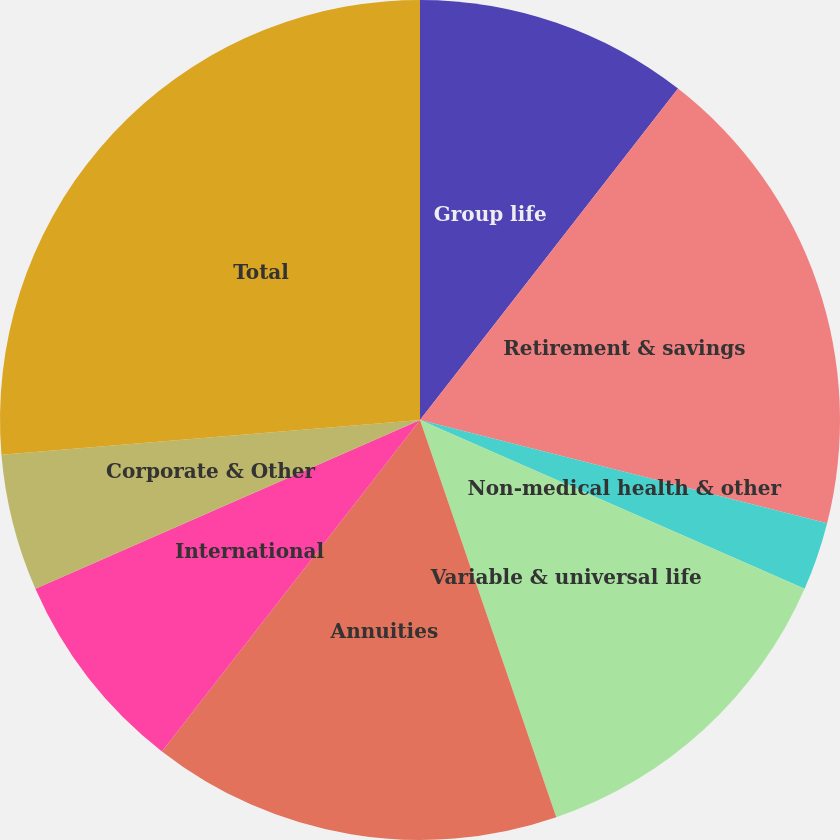<chart> <loc_0><loc_0><loc_500><loc_500><pie_chart><fcel>Group life<fcel>Retirement & savings<fcel>Non-medical health & other<fcel>Traditional life<fcel>Variable & universal life<fcel>Annuities<fcel>International<fcel>Corporate & Other<fcel>Total<nl><fcel>10.53%<fcel>18.42%<fcel>2.63%<fcel>0.0%<fcel>13.16%<fcel>15.79%<fcel>7.89%<fcel>5.26%<fcel>26.32%<nl></chart> 